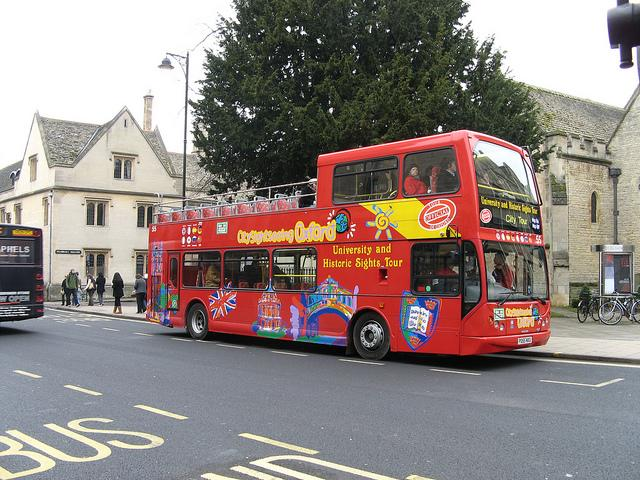Who are the passengers inside the red bus? tourists 